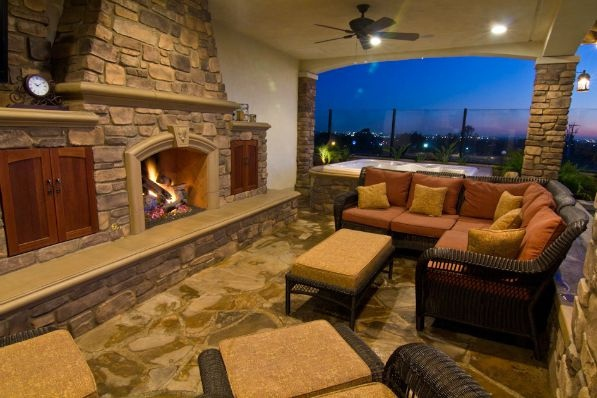Describe the objects in this image and their specific colors. I can see couch in black, maroon, and brown tones, chair in black, tan, maroon, and orange tones, and clock in black, lightgray, and darkgray tones in this image. 